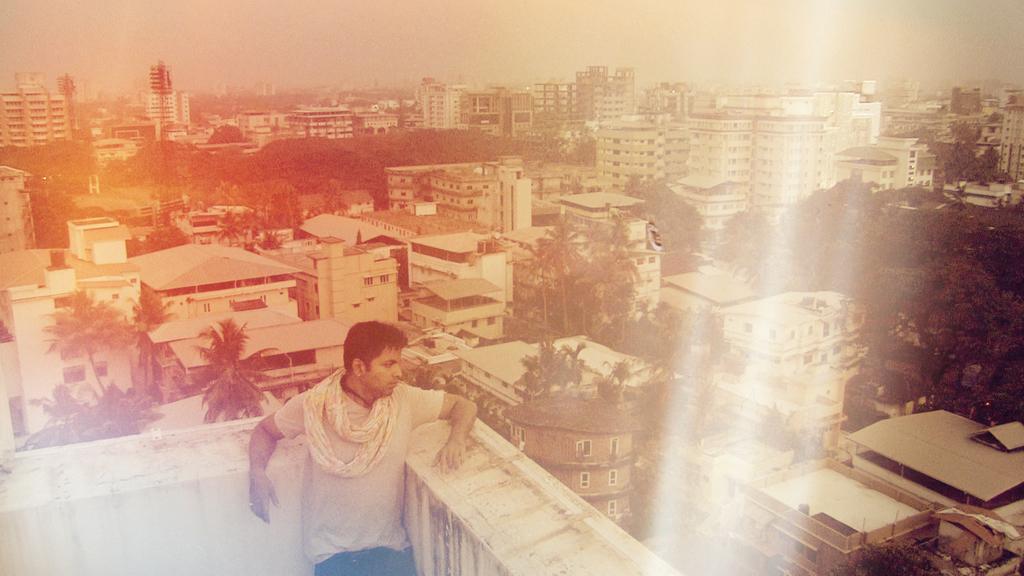Could you give a brief overview of what you see in this image? This picture shows a man standing on the building and we see trees and buildings and few lights to the towers. 